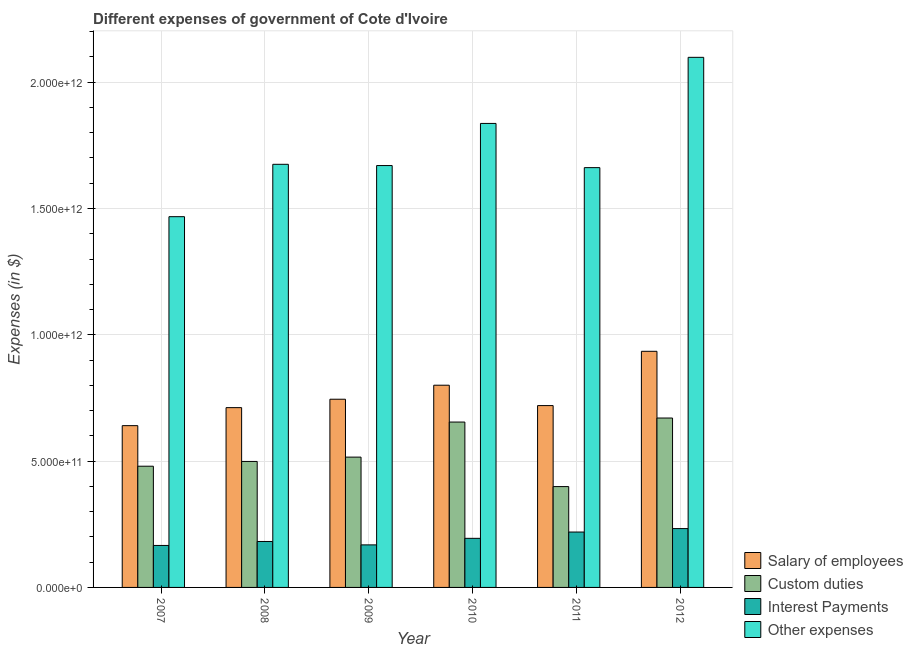How many different coloured bars are there?
Keep it short and to the point. 4. How many bars are there on the 3rd tick from the left?
Offer a terse response. 4. How many bars are there on the 5th tick from the right?
Give a very brief answer. 4. What is the label of the 3rd group of bars from the left?
Provide a succinct answer. 2009. What is the amount spent on other expenses in 2007?
Provide a short and direct response. 1.47e+12. Across all years, what is the maximum amount spent on interest payments?
Offer a very short reply. 2.33e+11. Across all years, what is the minimum amount spent on other expenses?
Provide a succinct answer. 1.47e+12. In which year was the amount spent on salary of employees maximum?
Give a very brief answer. 2012. What is the total amount spent on interest payments in the graph?
Give a very brief answer. 1.16e+12. What is the difference between the amount spent on interest payments in 2008 and that in 2009?
Provide a short and direct response. 1.35e+1. What is the difference between the amount spent on custom duties in 2009 and the amount spent on other expenses in 2011?
Ensure brevity in your answer.  1.17e+11. What is the average amount spent on salary of employees per year?
Your answer should be very brief. 7.59e+11. In the year 2010, what is the difference between the amount spent on custom duties and amount spent on salary of employees?
Offer a very short reply. 0. What is the ratio of the amount spent on salary of employees in 2009 to that in 2010?
Offer a terse response. 0.93. Is the amount spent on salary of employees in 2007 less than that in 2009?
Keep it short and to the point. Yes. Is the difference between the amount spent on custom duties in 2008 and 2011 greater than the difference between the amount spent on salary of employees in 2008 and 2011?
Provide a short and direct response. No. What is the difference between the highest and the second highest amount spent on interest payments?
Provide a short and direct response. 1.37e+1. What is the difference between the highest and the lowest amount spent on salary of employees?
Provide a succinct answer. 2.94e+11. In how many years, is the amount spent on other expenses greater than the average amount spent on other expenses taken over all years?
Provide a short and direct response. 2. What does the 1st bar from the left in 2012 represents?
Provide a succinct answer. Salary of employees. What does the 2nd bar from the right in 2011 represents?
Offer a very short reply. Interest Payments. How many years are there in the graph?
Keep it short and to the point. 6. What is the difference between two consecutive major ticks on the Y-axis?
Provide a succinct answer. 5.00e+11. Are the values on the major ticks of Y-axis written in scientific E-notation?
Give a very brief answer. Yes. Does the graph contain any zero values?
Provide a short and direct response. No. Does the graph contain grids?
Ensure brevity in your answer.  Yes. How are the legend labels stacked?
Your answer should be compact. Vertical. What is the title of the graph?
Keep it short and to the point. Different expenses of government of Cote d'Ivoire. What is the label or title of the X-axis?
Make the answer very short. Year. What is the label or title of the Y-axis?
Your response must be concise. Expenses (in $). What is the Expenses (in $) of Salary of employees in 2007?
Your response must be concise. 6.40e+11. What is the Expenses (in $) of Custom duties in 2007?
Provide a succinct answer. 4.80e+11. What is the Expenses (in $) in Interest Payments in 2007?
Provide a short and direct response. 1.66e+11. What is the Expenses (in $) of Other expenses in 2007?
Make the answer very short. 1.47e+12. What is the Expenses (in $) in Salary of employees in 2008?
Make the answer very short. 7.12e+11. What is the Expenses (in $) of Custom duties in 2008?
Provide a short and direct response. 4.99e+11. What is the Expenses (in $) in Interest Payments in 2008?
Provide a succinct answer. 1.82e+11. What is the Expenses (in $) in Other expenses in 2008?
Your answer should be compact. 1.67e+12. What is the Expenses (in $) of Salary of employees in 2009?
Give a very brief answer. 7.45e+11. What is the Expenses (in $) in Custom duties in 2009?
Provide a succinct answer. 5.16e+11. What is the Expenses (in $) of Interest Payments in 2009?
Provide a short and direct response. 1.68e+11. What is the Expenses (in $) in Other expenses in 2009?
Your answer should be compact. 1.67e+12. What is the Expenses (in $) of Salary of employees in 2010?
Provide a succinct answer. 8.00e+11. What is the Expenses (in $) in Custom duties in 2010?
Keep it short and to the point. 6.55e+11. What is the Expenses (in $) in Interest Payments in 2010?
Your response must be concise. 1.94e+11. What is the Expenses (in $) of Other expenses in 2010?
Provide a short and direct response. 1.84e+12. What is the Expenses (in $) of Salary of employees in 2011?
Your answer should be compact. 7.20e+11. What is the Expenses (in $) in Custom duties in 2011?
Make the answer very short. 3.99e+11. What is the Expenses (in $) of Interest Payments in 2011?
Your answer should be very brief. 2.19e+11. What is the Expenses (in $) in Other expenses in 2011?
Keep it short and to the point. 1.66e+12. What is the Expenses (in $) of Salary of employees in 2012?
Your answer should be compact. 9.35e+11. What is the Expenses (in $) in Custom duties in 2012?
Provide a succinct answer. 6.71e+11. What is the Expenses (in $) in Interest Payments in 2012?
Your answer should be compact. 2.33e+11. What is the Expenses (in $) in Other expenses in 2012?
Your answer should be very brief. 2.10e+12. Across all years, what is the maximum Expenses (in $) in Salary of employees?
Provide a succinct answer. 9.35e+11. Across all years, what is the maximum Expenses (in $) of Custom duties?
Your answer should be very brief. 6.71e+11. Across all years, what is the maximum Expenses (in $) of Interest Payments?
Your answer should be very brief. 2.33e+11. Across all years, what is the maximum Expenses (in $) of Other expenses?
Your response must be concise. 2.10e+12. Across all years, what is the minimum Expenses (in $) of Salary of employees?
Give a very brief answer. 6.40e+11. Across all years, what is the minimum Expenses (in $) in Custom duties?
Your answer should be very brief. 3.99e+11. Across all years, what is the minimum Expenses (in $) in Interest Payments?
Provide a short and direct response. 1.66e+11. Across all years, what is the minimum Expenses (in $) of Other expenses?
Make the answer very short. 1.47e+12. What is the total Expenses (in $) in Salary of employees in the graph?
Your response must be concise. 4.55e+12. What is the total Expenses (in $) of Custom duties in the graph?
Provide a succinct answer. 3.22e+12. What is the total Expenses (in $) in Interest Payments in the graph?
Provide a short and direct response. 1.16e+12. What is the total Expenses (in $) of Other expenses in the graph?
Ensure brevity in your answer.  1.04e+13. What is the difference between the Expenses (in $) of Salary of employees in 2007 and that in 2008?
Give a very brief answer. -7.13e+1. What is the difference between the Expenses (in $) in Custom duties in 2007 and that in 2008?
Offer a terse response. -1.89e+1. What is the difference between the Expenses (in $) of Interest Payments in 2007 and that in 2008?
Offer a very short reply. -1.57e+1. What is the difference between the Expenses (in $) in Other expenses in 2007 and that in 2008?
Offer a terse response. -2.07e+11. What is the difference between the Expenses (in $) in Salary of employees in 2007 and that in 2009?
Your response must be concise. -1.05e+11. What is the difference between the Expenses (in $) in Custom duties in 2007 and that in 2009?
Give a very brief answer. -3.60e+1. What is the difference between the Expenses (in $) in Interest Payments in 2007 and that in 2009?
Offer a terse response. -2.23e+09. What is the difference between the Expenses (in $) in Other expenses in 2007 and that in 2009?
Your answer should be compact. -2.02e+11. What is the difference between the Expenses (in $) in Salary of employees in 2007 and that in 2010?
Offer a very short reply. -1.60e+11. What is the difference between the Expenses (in $) in Custom duties in 2007 and that in 2010?
Ensure brevity in your answer.  -1.75e+11. What is the difference between the Expenses (in $) of Interest Payments in 2007 and that in 2010?
Keep it short and to the point. -2.81e+1. What is the difference between the Expenses (in $) of Other expenses in 2007 and that in 2010?
Your answer should be compact. -3.69e+11. What is the difference between the Expenses (in $) in Salary of employees in 2007 and that in 2011?
Your answer should be very brief. -7.94e+1. What is the difference between the Expenses (in $) in Custom duties in 2007 and that in 2011?
Your answer should be very brief. 8.06e+1. What is the difference between the Expenses (in $) of Interest Payments in 2007 and that in 2011?
Provide a succinct answer. -5.30e+1. What is the difference between the Expenses (in $) in Other expenses in 2007 and that in 2011?
Provide a short and direct response. -1.94e+11. What is the difference between the Expenses (in $) of Salary of employees in 2007 and that in 2012?
Your answer should be compact. -2.94e+11. What is the difference between the Expenses (in $) of Custom duties in 2007 and that in 2012?
Keep it short and to the point. -1.91e+11. What is the difference between the Expenses (in $) in Interest Payments in 2007 and that in 2012?
Offer a terse response. -6.67e+1. What is the difference between the Expenses (in $) of Other expenses in 2007 and that in 2012?
Your response must be concise. -6.31e+11. What is the difference between the Expenses (in $) of Salary of employees in 2008 and that in 2009?
Your answer should be very brief. -3.33e+1. What is the difference between the Expenses (in $) in Custom duties in 2008 and that in 2009?
Offer a very short reply. -1.71e+1. What is the difference between the Expenses (in $) of Interest Payments in 2008 and that in 2009?
Give a very brief answer. 1.35e+1. What is the difference between the Expenses (in $) in Other expenses in 2008 and that in 2009?
Keep it short and to the point. 4.94e+09. What is the difference between the Expenses (in $) of Salary of employees in 2008 and that in 2010?
Your response must be concise. -8.88e+1. What is the difference between the Expenses (in $) of Custom duties in 2008 and that in 2010?
Keep it short and to the point. -1.56e+11. What is the difference between the Expenses (in $) of Interest Payments in 2008 and that in 2010?
Offer a terse response. -1.24e+1. What is the difference between the Expenses (in $) in Other expenses in 2008 and that in 2010?
Offer a very short reply. -1.62e+11. What is the difference between the Expenses (in $) of Salary of employees in 2008 and that in 2011?
Offer a very short reply. -8.10e+09. What is the difference between the Expenses (in $) of Custom duties in 2008 and that in 2011?
Provide a succinct answer. 9.95e+1. What is the difference between the Expenses (in $) of Interest Payments in 2008 and that in 2011?
Your answer should be compact. -3.74e+1. What is the difference between the Expenses (in $) of Other expenses in 2008 and that in 2011?
Offer a terse response. 1.32e+1. What is the difference between the Expenses (in $) in Salary of employees in 2008 and that in 2012?
Your answer should be very brief. -2.23e+11. What is the difference between the Expenses (in $) in Custom duties in 2008 and that in 2012?
Offer a terse response. -1.72e+11. What is the difference between the Expenses (in $) of Interest Payments in 2008 and that in 2012?
Your answer should be compact. -5.10e+1. What is the difference between the Expenses (in $) of Other expenses in 2008 and that in 2012?
Give a very brief answer. -4.23e+11. What is the difference between the Expenses (in $) in Salary of employees in 2009 and that in 2010?
Keep it short and to the point. -5.55e+1. What is the difference between the Expenses (in $) of Custom duties in 2009 and that in 2010?
Provide a short and direct response. -1.39e+11. What is the difference between the Expenses (in $) of Interest Payments in 2009 and that in 2010?
Offer a very short reply. -2.59e+1. What is the difference between the Expenses (in $) of Other expenses in 2009 and that in 2010?
Your response must be concise. -1.67e+11. What is the difference between the Expenses (in $) in Salary of employees in 2009 and that in 2011?
Provide a succinct answer. 2.52e+1. What is the difference between the Expenses (in $) in Custom duties in 2009 and that in 2011?
Keep it short and to the point. 1.17e+11. What is the difference between the Expenses (in $) of Interest Payments in 2009 and that in 2011?
Provide a short and direct response. -5.08e+1. What is the difference between the Expenses (in $) of Other expenses in 2009 and that in 2011?
Offer a terse response. 8.24e+09. What is the difference between the Expenses (in $) of Salary of employees in 2009 and that in 2012?
Provide a short and direct response. -1.90e+11. What is the difference between the Expenses (in $) in Custom duties in 2009 and that in 2012?
Provide a short and direct response. -1.55e+11. What is the difference between the Expenses (in $) in Interest Payments in 2009 and that in 2012?
Keep it short and to the point. -6.45e+1. What is the difference between the Expenses (in $) in Other expenses in 2009 and that in 2012?
Give a very brief answer. -4.28e+11. What is the difference between the Expenses (in $) of Salary of employees in 2010 and that in 2011?
Your answer should be compact. 8.07e+1. What is the difference between the Expenses (in $) in Custom duties in 2010 and that in 2011?
Keep it short and to the point. 2.55e+11. What is the difference between the Expenses (in $) of Interest Payments in 2010 and that in 2011?
Give a very brief answer. -2.49e+1. What is the difference between the Expenses (in $) of Other expenses in 2010 and that in 2011?
Your answer should be compact. 1.75e+11. What is the difference between the Expenses (in $) in Salary of employees in 2010 and that in 2012?
Provide a short and direct response. -1.34e+11. What is the difference between the Expenses (in $) in Custom duties in 2010 and that in 2012?
Provide a succinct answer. -1.60e+1. What is the difference between the Expenses (in $) of Interest Payments in 2010 and that in 2012?
Your answer should be compact. -3.86e+1. What is the difference between the Expenses (in $) in Other expenses in 2010 and that in 2012?
Provide a succinct answer. -2.62e+11. What is the difference between the Expenses (in $) in Salary of employees in 2011 and that in 2012?
Ensure brevity in your answer.  -2.15e+11. What is the difference between the Expenses (in $) in Custom duties in 2011 and that in 2012?
Provide a succinct answer. -2.71e+11. What is the difference between the Expenses (in $) of Interest Payments in 2011 and that in 2012?
Keep it short and to the point. -1.37e+1. What is the difference between the Expenses (in $) in Other expenses in 2011 and that in 2012?
Offer a very short reply. -4.37e+11. What is the difference between the Expenses (in $) in Salary of employees in 2007 and the Expenses (in $) in Custom duties in 2008?
Provide a short and direct response. 1.42e+11. What is the difference between the Expenses (in $) of Salary of employees in 2007 and the Expenses (in $) of Interest Payments in 2008?
Your answer should be compact. 4.58e+11. What is the difference between the Expenses (in $) in Salary of employees in 2007 and the Expenses (in $) in Other expenses in 2008?
Your answer should be very brief. -1.03e+12. What is the difference between the Expenses (in $) of Custom duties in 2007 and the Expenses (in $) of Interest Payments in 2008?
Provide a short and direct response. 2.98e+11. What is the difference between the Expenses (in $) in Custom duties in 2007 and the Expenses (in $) in Other expenses in 2008?
Your response must be concise. -1.20e+12. What is the difference between the Expenses (in $) of Interest Payments in 2007 and the Expenses (in $) of Other expenses in 2008?
Your answer should be compact. -1.51e+12. What is the difference between the Expenses (in $) in Salary of employees in 2007 and the Expenses (in $) in Custom duties in 2009?
Provide a short and direct response. 1.25e+11. What is the difference between the Expenses (in $) in Salary of employees in 2007 and the Expenses (in $) in Interest Payments in 2009?
Provide a short and direct response. 4.72e+11. What is the difference between the Expenses (in $) of Salary of employees in 2007 and the Expenses (in $) of Other expenses in 2009?
Offer a terse response. -1.03e+12. What is the difference between the Expenses (in $) in Custom duties in 2007 and the Expenses (in $) in Interest Payments in 2009?
Keep it short and to the point. 3.11e+11. What is the difference between the Expenses (in $) in Custom duties in 2007 and the Expenses (in $) in Other expenses in 2009?
Ensure brevity in your answer.  -1.19e+12. What is the difference between the Expenses (in $) of Interest Payments in 2007 and the Expenses (in $) of Other expenses in 2009?
Give a very brief answer. -1.50e+12. What is the difference between the Expenses (in $) in Salary of employees in 2007 and the Expenses (in $) in Custom duties in 2010?
Make the answer very short. -1.42e+1. What is the difference between the Expenses (in $) of Salary of employees in 2007 and the Expenses (in $) of Interest Payments in 2010?
Keep it short and to the point. 4.46e+11. What is the difference between the Expenses (in $) of Salary of employees in 2007 and the Expenses (in $) of Other expenses in 2010?
Make the answer very short. -1.20e+12. What is the difference between the Expenses (in $) in Custom duties in 2007 and the Expenses (in $) in Interest Payments in 2010?
Offer a terse response. 2.85e+11. What is the difference between the Expenses (in $) in Custom duties in 2007 and the Expenses (in $) in Other expenses in 2010?
Your response must be concise. -1.36e+12. What is the difference between the Expenses (in $) of Interest Payments in 2007 and the Expenses (in $) of Other expenses in 2010?
Make the answer very short. -1.67e+12. What is the difference between the Expenses (in $) in Salary of employees in 2007 and the Expenses (in $) in Custom duties in 2011?
Offer a very short reply. 2.41e+11. What is the difference between the Expenses (in $) in Salary of employees in 2007 and the Expenses (in $) in Interest Payments in 2011?
Offer a terse response. 4.21e+11. What is the difference between the Expenses (in $) in Salary of employees in 2007 and the Expenses (in $) in Other expenses in 2011?
Offer a terse response. -1.02e+12. What is the difference between the Expenses (in $) in Custom duties in 2007 and the Expenses (in $) in Interest Payments in 2011?
Your answer should be very brief. 2.61e+11. What is the difference between the Expenses (in $) of Custom duties in 2007 and the Expenses (in $) of Other expenses in 2011?
Your answer should be compact. -1.18e+12. What is the difference between the Expenses (in $) in Interest Payments in 2007 and the Expenses (in $) in Other expenses in 2011?
Keep it short and to the point. -1.50e+12. What is the difference between the Expenses (in $) of Salary of employees in 2007 and the Expenses (in $) of Custom duties in 2012?
Provide a short and direct response. -3.02e+1. What is the difference between the Expenses (in $) in Salary of employees in 2007 and the Expenses (in $) in Interest Payments in 2012?
Your response must be concise. 4.07e+11. What is the difference between the Expenses (in $) of Salary of employees in 2007 and the Expenses (in $) of Other expenses in 2012?
Your answer should be very brief. -1.46e+12. What is the difference between the Expenses (in $) in Custom duties in 2007 and the Expenses (in $) in Interest Payments in 2012?
Make the answer very short. 2.47e+11. What is the difference between the Expenses (in $) of Custom duties in 2007 and the Expenses (in $) of Other expenses in 2012?
Keep it short and to the point. -1.62e+12. What is the difference between the Expenses (in $) in Interest Payments in 2007 and the Expenses (in $) in Other expenses in 2012?
Ensure brevity in your answer.  -1.93e+12. What is the difference between the Expenses (in $) in Salary of employees in 2008 and the Expenses (in $) in Custom duties in 2009?
Offer a very short reply. 1.96e+11. What is the difference between the Expenses (in $) in Salary of employees in 2008 and the Expenses (in $) in Interest Payments in 2009?
Your response must be concise. 5.43e+11. What is the difference between the Expenses (in $) of Salary of employees in 2008 and the Expenses (in $) of Other expenses in 2009?
Give a very brief answer. -9.58e+11. What is the difference between the Expenses (in $) in Custom duties in 2008 and the Expenses (in $) in Interest Payments in 2009?
Offer a very short reply. 3.30e+11. What is the difference between the Expenses (in $) in Custom duties in 2008 and the Expenses (in $) in Other expenses in 2009?
Ensure brevity in your answer.  -1.17e+12. What is the difference between the Expenses (in $) of Interest Payments in 2008 and the Expenses (in $) of Other expenses in 2009?
Your answer should be very brief. -1.49e+12. What is the difference between the Expenses (in $) in Salary of employees in 2008 and the Expenses (in $) in Custom duties in 2010?
Provide a short and direct response. 5.71e+1. What is the difference between the Expenses (in $) of Salary of employees in 2008 and the Expenses (in $) of Interest Payments in 2010?
Give a very brief answer. 5.17e+11. What is the difference between the Expenses (in $) of Salary of employees in 2008 and the Expenses (in $) of Other expenses in 2010?
Keep it short and to the point. -1.13e+12. What is the difference between the Expenses (in $) in Custom duties in 2008 and the Expenses (in $) in Interest Payments in 2010?
Offer a terse response. 3.04e+11. What is the difference between the Expenses (in $) in Custom duties in 2008 and the Expenses (in $) in Other expenses in 2010?
Offer a terse response. -1.34e+12. What is the difference between the Expenses (in $) of Interest Payments in 2008 and the Expenses (in $) of Other expenses in 2010?
Provide a short and direct response. -1.65e+12. What is the difference between the Expenses (in $) of Salary of employees in 2008 and the Expenses (in $) of Custom duties in 2011?
Offer a terse response. 3.12e+11. What is the difference between the Expenses (in $) in Salary of employees in 2008 and the Expenses (in $) in Interest Payments in 2011?
Give a very brief answer. 4.92e+11. What is the difference between the Expenses (in $) in Salary of employees in 2008 and the Expenses (in $) in Other expenses in 2011?
Offer a very short reply. -9.50e+11. What is the difference between the Expenses (in $) of Custom duties in 2008 and the Expenses (in $) of Interest Payments in 2011?
Provide a succinct answer. 2.79e+11. What is the difference between the Expenses (in $) in Custom duties in 2008 and the Expenses (in $) in Other expenses in 2011?
Offer a terse response. -1.16e+12. What is the difference between the Expenses (in $) of Interest Payments in 2008 and the Expenses (in $) of Other expenses in 2011?
Offer a terse response. -1.48e+12. What is the difference between the Expenses (in $) of Salary of employees in 2008 and the Expenses (in $) of Custom duties in 2012?
Keep it short and to the point. 4.11e+1. What is the difference between the Expenses (in $) in Salary of employees in 2008 and the Expenses (in $) in Interest Payments in 2012?
Your response must be concise. 4.79e+11. What is the difference between the Expenses (in $) in Salary of employees in 2008 and the Expenses (in $) in Other expenses in 2012?
Your response must be concise. -1.39e+12. What is the difference between the Expenses (in $) of Custom duties in 2008 and the Expenses (in $) of Interest Payments in 2012?
Give a very brief answer. 2.66e+11. What is the difference between the Expenses (in $) in Custom duties in 2008 and the Expenses (in $) in Other expenses in 2012?
Your response must be concise. -1.60e+12. What is the difference between the Expenses (in $) in Interest Payments in 2008 and the Expenses (in $) in Other expenses in 2012?
Your answer should be compact. -1.92e+12. What is the difference between the Expenses (in $) in Salary of employees in 2009 and the Expenses (in $) in Custom duties in 2010?
Offer a very short reply. 9.04e+1. What is the difference between the Expenses (in $) of Salary of employees in 2009 and the Expenses (in $) of Interest Payments in 2010?
Give a very brief answer. 5.51e+11. What is the difference between the Expenses (in $) of Salary of employees in 2009 and the Expenses (in $) of Other expenses in 2010?
Your response must be concise. -1.09e+12. What is the difference between the Expenses (in $) in Custom duties in 2009 and the Expenses (in $) in Interest Payments in 2010?
Your response must be concise. 3.21e+11. What is the difference between the Expenses (in $) of Custom duties in 2009 and the Expenses (in $) of Other expenses in 2010?
Ensure brevity in your answer.  -1.32e+12. What is the difference between the Expenses (in $) of Interest Payments in 2009 and the Expenses (in $) of Other expenses in 2010?
Provide a short and direct response. -1.67e+12. What is the difference between the Expenses (in $) of Salary of employees in 2009 and the Expenses (in $) of Custom duties in 2011?
Give a very brief answer. 3.46e+11. What is the difference between the Expenses (in $) in Salary of employees in 2009 and the Expenses (in $) in Interest Payments in 2011?
Your answer should be very brief. 5.26e+11. What is the difference between the Expenses (in $) in Salary of employees in 2009 and the Expenses (in $) in Other expenses in 2011?
Your answer should be compact. -9.17e+11. What is the difference between the Expenses (in $) in Custom duties in 2009 and the Expenses (in $) in Interest Payments in 2011?
Give a very brief answer. 2.97e+11. What is the difference between the Expenses (in $) in Custom duties in 2009 and the Expenses (in $) in Other expenses in 2011?
Offer a terse response. -1.15e+12. What is the difference between the Expenses (in $) in Interest Payments in 2009 and the Expenses (in $) in Other expenses in 2011?
Ensure brevity in your answer.  -1.49e+12. What is the difference between the Expenses (in $) in Salary of employees in 2009 and the Expenses (in $) in Custom duties in 2012?
Offer a very short reply. 7.44e+1. What is the difference between the Expenses (in $) of Salary of employees in 2009 and the Expenses (in $) of Interest Payments in 2012?
Keep it short and to the point. 5.12e+11. What is the difference between the Expenses (in $) in Salary of employees in 2009 and the Expenses (in $) in Other expenses in 2012?
Provide a short and direct response. -1.35e+12. What is the difference between the Expenses (in $) of Custom duties in 2009 and the Expenses (in $) of Interest Payments in 2012?
Provide a short and direct response. 2.83e+11. What is the difference between the Expenses (in $) of Custom duties in 2009 and the Expenses (in $) of Other expenses in 2012?
Provide a short and direct response. -1.58e+12. What is the difference between the Expenses (in $) in Interest Payments in 2009 and the Expenses (in $) in Other expenses in 2012?
Your answer should be very brief. -1.93e+12. What is the difference between the Expenses (in $) in Salary of employees in 2010 and the Expenses (in $) in Custom duties in 2011?
Keep it short and to the point. 4.01e+11. What is the difference between the Expenses (in $) of Salary of employees in 2010 and the Expenses (in $) of Interest Payments in 2011?
Provide a succinct answer. 5.81e+11. What is the difference between the Expenses (in $) of Salary of employees in 2010 and the Expenses (in $) of Other expenses in 2011?
Provide a succinct answer. -8.61e+11. What is the difference between the Expenses (in $) of Custom duties in 2010 and the Expenses (in $) of Interest Payments in 2011?
Your response must be concise. 4.35e+11. What is the difference between the Expenses (in $) in Custom duties in 2010 and the Expenses (in $) in Other expenses in 2011?
Provide a succinct answer. -1.01e+12. What is the difference between the Expenses (in $) in Interest Payments in 2010 and the Expenses (in $) in Other expenses in 2011?
Your answer should be very brief. -1.47e+12. What is the difference between the Expenses (in $) in Salary of employees in 2010 and the Expenses (in $) in Custom duties in 2012?
Give a very brief answer. 1.30e+11. What is the difference between the Expenses (in $) of Salary of employees in 2010 and the Expenses (in $) of Interest Payments in 2012?
Give a very brief answer. 5.68e+11. What is the difference between the Expenses (in $) in Salary of employees in 2010 and the Expenses (in $) in Other expenses in 2012?
Your response must be concise. -1.30e+12. What is the difference between the Expenses (in $) of Custom duties in 2010 and the Expenses (in $) of Interest Payments in 2012?
Your answer should be very brief. 4.22e+11. What is the difference between the Expenses (in $) of Custom duties in 2010 and the Expenses (in $) of Other expenses in 2012?
Make the answer very short. -1.44e+12. What is the difference between the Expenses (in $) of Interest Payments in 2010 and the Expenses (in $) of Other expenses in 2012?
Keep it short and to the point. -1.90e+12. What is the difference between the Expenses (in $) of Salary of employees in 2011 and the Expenses (in $) of Custom duties in 2012?
Keep it short and to the point. 4.92e+1. What is the difference between the Expenses (in $) in Salary of employees in 2011 and the Expenses (in $) in Interest Payments in 2012?
Keep it short and to the point. 4.87e+11. What is the difference between the Expenses (in $) in Salary of employees in 2011 and the Expenses (in $) in Other expenses in 2012?
Provide a succinct answer. -1.38e+12. What is the difference between the Expenses (in $) of Custom duties in 2011 and the Expenses (in $) of Interest Payments in 2012?
Give a very brief answer. 1.66e+11. What is the difference between the Expenses (in $) of Custom duties in 2011 and the Expenses (in $) of Other expenses in 2012?
Your response must be concise. -1.70e+12. What is the difference between the Expenses (in $) of Interest Payments in 2011 and the Expenses (in $) of Other expenses in 2012?
Keep it short and to the point. -1.88e+12. What is the average Expenses (in $) of Salary of employees per year?
Provide a succinct answer. 7.59e+11. What is the average Expenses (in $) of Custom duties per year?
Your answer should be compact. 5.36e+11. What is the average Expenses (in $) of Interest Payments per year?
Give a very brief answer. 1.94e+11. What is the average Expenses (in $) of Other expenses per year?
Your answer should be very brief. 1.73e+12. In the year 2007, what is the difference between the Expenses (in $) in Salary of employees and Expenses (in $) in Custom duties?
Ensure brevity in your answer.  1.61e+11. In the year 2007, what is the difference between the Expenses (in $) in Salary of employees and Expenses (in $) in Interest Payments?
Provide a succinct answer. 4.74e+11. In the year 2007, what is the difference between the Expenses (in $) in Salary of employees and Expenses (in $) in Other expenses?
Your answer should be compact. -8.27e+11. In the year 2007, what is the difference between the Expenses (in $) in Custom duties and Expenses (in $) in Interest Payments?
Provide a succinct answer. 3.14e+11. In the year 2007, what is the difference between the Expenses (in $) of Custom duties and Expenses (in $) of Other expenses?
Your answer should be very brief. -9.88e+11. In the year 2007, what is the difference between the Expenses (in $) in Interest Payments and Expenses (in $) in Other expenses?
Ensure brevity in your answer.  -1.30e+12. In the year 2008, what is the difference between the Expenses (in $) in Salary of employees and Expenses (in $) in Custom duties?
Offer a terse response. 2.13e+11. In the year 2008, what is the difference between the Expenses (in $) of Salary of employees and Expenses (in $) of Interest Payments?
Give a very brief answer. 5.30e+11. In the year 2008, what is the difference between the Expenses (in $) of Salary of employees and Expenses (in $) of Other expenses?
Provide a short and direct response. -9.63e+11. In the year 2008, what is the difference between the Expenses (in $) in Custom duties and Expenses (in $) in Interest Payments?
Make the answer very short. 3.17e+11. In the year 2008, what is the difference between the Expenses (in $) of Custom duties and Expenses (in $) of Other expenses?
Make the answer very short. -1.18e+12. In the year 2008, what is the difference between the Expenses (in $) of Interest Payments and Expenses (in $) of Other expenses?
Your answer should be compact. -1.49e+12. In the year 2009, what is the difference between the Expenses (in $) of Salary of employees and Expenses (in $) of Custom duties?
Offer a very short reply. 2.29e+11. In the year 2009, what is the difference between the Expenses (in $) of Salary of employees and Expenses (in $) of Interest Payments?
Your answer should be compact. 5.77e+11. In the year 2009, what is the difference between the Expenses (in $) in Salary of employees and Expenses (in $) in Other expenses?
Give a very brief answer. -9.25e+11. In the year 2009, what is the difference between the Expenses (in $) in Custom duties and Expenses (in $) in Interest Payments?
Offer a very short reply. 3.47e+11. In the year 2009, what is the difference between the Expenses (in $) of Custom duties and Expenses (in $) of Other expenses?
Keep it short and to the point. -1.15e+12. In the year 2009, what is the difference between the Expenses (in $) of Interest Payments and Expenses (in $) of Other expenses?
Your answer should be very brief. -1.50e+12. In the year 2010, what is the difference between the Expenses (in $) in Salary of employees and Expenses (in $) in Custom duties?
Offer a very short reply. 1.46e+11. In the year 2010, what is the difference between the Expenses (in $) of Salary of employees and Expenses (in $) of Interest Payments?
Give a very brief answer. 6.06e+11. In the year 2010, what is the difference between the Expenses (in $) of Salary of employees and Expenses (in $) of Other expenses?
Provide a short and direct response. -1.04e+12. In the year 2010, what is the difference between the Expenses (in $) in Custom duties and Expenses (in $) in Interest Payments?
Your answer should be very brief. 4.60e+11. In the year 2010, what is the difference between the Expenses (in $) in Custom duties and Expenses (in $) in Other expenses?
Offer a very short reply. -1.18e+12. In the year 2010, what is the difference between the Expenses (in $) in Interest Payments and Expenses (in $) in Other expenses?
Give a very brief answer. -1.64e+12. In the year 2011, what is the difference between the Expenses (in $) in Salary of employees and Expenses (in $) in Custom duties?
Your response must be concise. 3.21e+11. In the year 2011, what is the difference between the Expenses (in $) of Salary of employees and Expenses (in $) of Interest Payments?
Your answer should be very brief. 5.01e+11. In the year 2011, what is the difference between the Expenses (in $) in Salary of employees and Expenses (in $) in Other expenses?
Make the answer very short. -9.42e+11. In the year 2011, what is the difference between the Expenses (in $) in Custom duties and Expenses (in $) in Interest Payments?
Your response must be concise. 1.80e+11. In the year 2011, what is the difference between the Expenses (in $) of Custom duties and Expenses (in $) of Other expenses?
Give a very brief answer. -1.26e+12. In the year 2011, what is the difference between the Expenses (in $) in Interest Payments and Expenses (in $) in Other expenses?
Provide a succinct answer. -1.44e+12. In the year 2012, what is the difference between the Expenses (in $) in Salary of employees and Expenses (in $) in Custom duties?
Provide a short and direct response. 2.64e+11. In the year 2012, what is the difference between the Expenses (in $) in Salary of employees and Expenses (in $) in Interest Payments?
Give a very brief answer. 7.02e+11. In the year 2012, what is the difference between the Expenses (in $) of Salary of employees and Expenses (in $) of Other expenses?
Ensure brevity in your answer.  -1.16e+12. In the year 2012, what is the difference between the Expenses (in $) in Custom duties and Expenses (in $) in Interest Payments?
Provide a succinct answer. 4.38e+11. In the year 2012, what is the difference between the Expenses (in $) in Custom duties and Expenses (in $) in Other expenses?
Give a very brief answer. -1.43e+12. In the year 2012, what is the difference between the Expenses (in $) in Interest Payments and Expenses (in $) in Other expenses?
Make the answer very short. -1.87e+12. What is the ratio of the Expenses (in $) in Salary of employees in 2007 to that in 2008?
Offer a terse response. 0.9. What is the ratio of the Expenses (in $) in Custom duties in 2007 to that in 2008?
Offer a terse response. 0.96. What is the ratio of the Expenses (in $) in Interest Payments in 2007 to that in 2008?
Ensure brevity in your answer.  0.91. What is the ratio of the Expenses (in $) of Other expenses in 2007 to that in 2008?
Provide a short and direct response. 0.88. What is the ratio of the Expenses (in $) in Salary of employees in 2007 to that in 2009?
Offer a very short reply. 0.86. What is the ratio of the Expenses (in $) in Custom duties in 2007 to that in 2009?
Your response must be concise. 0.93. What is the ratio of the Expenses (in $) in Interest Payments in 2007 to that in 2009?
Your response must be concise. 0.99. What is the ratio of the Expenses (in $) in Other expenses in 2007 to that in 2009?
Offer a terse response. 0.88. What is the ratio of the Expenses (in $) of Custom duties in 2007 to that in 2010?
Keep it short and to the point. 0.73. What is the ratio of the Expenses (in $) of Interest Payments in 2007 to that in 2010?
Your response must be concise. 0.86. What is the ratio of the Expenses (in $) in Other expenses in 2007 to that in 2010?
Make the answer very short. 0.8. What is the ratio of the Expenses (in $) of Salary of employees in 2007 to that in 2011?
Your response must be concise. 0.89. What is the ratio of the Expenses (in $) in Custom duties in 2007 to that in 2011?
Offer a very short reply. 1.2. What is the ratio of the Expenses (in $) of Interest Payments in 2007 to that in 2011?
Your answer should be compact. 0.76. What is the ratio of the Expenses (in $) of Other expenses in 2007 to that in 2011?
Your response must be concise. 0.88. What is the ratio of the Expenses (in $) in Salary of employees in 2007 to that in 2012?
Keep it short and to the point. 0.69. What is the ratio of the Expenses (in $) in Custom duties in 2007 to that in 2012?
Ensure brevity in your answer.  0.72. What is the ratio of the Expenses (in $) in Interest Payments in 2007 to that in 2012?
Offer a very short reply. 0.71. What is the ratio of the Expenses (in $) of Other expenses in 2007 to that in 2012?
Ensure brevity in your answer.  0.7. What is the ratio of the Expenses (in $) in Salary of employees in 2008 to that in 2009?
Provide a short and direct response. 0.96. What is the ratio of the Expenses (in $) in Custom duties in 2008 to that in 2009?
Provide a succinct answer. 0.97. What is the ratio of the Expenses (in $) in Salary of employees in 2008 to that in 2010?
Give a very brief answer. 0.89. What is the ratio of the Expenses (in $) of Custom duties in 2008 to that in 2010?
Ensure brevity in your answer.  0.76. What is the ratio of the Expenses (in $) in Interest Payments in 2008 to that in 2010?
Provide a short and direct response. 0.94. What is the ratio of the Expenses (in $) of Other expenses in 2008 to that in 2010?
Make the answer very short. 0.91. What is the ratio of the Expenses (in $) in Salary of employees in 2008 to that in 2011?
Your response must be concise. 0.99. What is the ratio of the Expenses (in $) of Custom duties in 2008 to that in 2011?
Offer a terse response. 1.25. What is the ratio of the Expenses (in $) of Interest Payments in 2008 to that in 2011?
Provide a succinct answer. 0.83. What is the ratio of the Expenses (in $) in Other expenses in 2008 to that in 2011?
Provide a short and direct response. 1.01. What is the ratio of the Expenses (in $) in Salary of employees in 2008 to that in 2012?
Offer a terse response. 0.76. What is the ratio of the Expenses (in $) in Custom duties in 2008 to that in 2012?
Keep it short and to the point. 0.74. What is the ratio of the Expenses (in $) of Interest Payments in 2008 to that in 2012?
Provide a short and direct response. 0.78. What is the ratio of the Expenses (in $) in Other expenses in 2008 to that in 2012?
Provide a succinct answer. 0.8. What is the ratio of the Expenses (in $) of Salary of employees in 2009 to that in 2010?
Ensure brevity in your answer.  0.93. What is the ratio of the Expenses (in $) in Custom duties in 2009 to that in 2010?
Provide a short and direct response. 0.79. What is the ratio of the Expenses (in $) in Interest Payments in 2009 to that in 2010?
Offer a very short reply. 0.87. What is the ratio of the Expenses (in $) of Other expenses in 2009 to that in 2010?
Your answer should be compact. 0.91. What is the ratio of the Expenses (in $) in Salary of employees in 2009 to that in 2011?
Your answer should be very brief. 1.03. What is the ratio of the Expenses (in $) of Custom duties in 2009 to that in 2011?
Your answer should be compact. 1.29. What is the ratio of the Expenses (in $) in Interest Payments in 2009 to that in 2011?
Provide a succinct answer. 0.77. What is the ratio of the Expenses (in $) in Salary of employees in 2009 to that in 2012?
Give a very brief answer. 0.8. What is the ratio of the Expenses (in $) of Custom duties in 2009 to that in 2012?
Ensure brevity in your answer.  0.77. What is the ratio of the Expenses (in $) of Interest Payments in 2009 to that in 2012?
Offer a terse response. 0.72. What is the ratio of the Expenses (in $) in Other expenses in 2009 to that in 2012?
Keep it short and to the point. 0.8. What is the ratio of the Expenses (in $) in Salary of employees in 2010 to that in 2011?
Keep it short and to the point. 1.11. What is the ratio of the Expenses (in $) of Custom duties in 2010 to that in 2011?
Give a very brief answer. 1.64. What is the ratio of the Expenses (in $) of Interest Payments in 2010 to that in 2011?
Give a very brief answer. 0.89. What is the ratio of the Expenses (in $) in Other expenses in 2010 to that in 2011?
Make the answer very short. 1.11. What is the ratio of the Expenses (in $) of Salary of employees in 2010 to that in 2012?
Ensure brevity in your answer.  0.86. What is the ratio of the Expenses (in $) of Custom duties in 2010 to that in 2012?
Your answer should be compact. 0.98. What is the ratio of the Expenses (in $) of Interest Payments in 2010 to that in 2012?
Your answer should be compact. 0.83. What is the ratio of the Expenses (in $) of Other expenses in 2010 to that in 2012?
Give a very brief answer. 0.88. What is the ratio of the Expenses (in $) of Salary of employees in 2011 to that in 2012?
Give a very brief answer. 0.77. What is the ratio of the Expenses (in $) of Custom duties in 2011 to that in 2012?
Offer a very short reply. 0.6. What is the ratio of the Expenses (in $) in Interest Payments in 2011 to that in 2012?
Provide a short and direct response. 0.94. What is the ratio of the Expenses (in $) of Other expenses in 2011 to that in 2012?
Offer a terse response. 0.79. What is the difference between the highest and the second highest Expenses (in $) in Salary of employees?
Provide a short and direct response. 1.34e+11. What is the difference between the highest and the second highest Expenses (in $) of Custom duties?
Offer a very short reply. 1.60e+1. What is the difference between the highest and the second highest Expenses (in $) of Interest Payments?
Your response must be concise. 1.37e+1. What is the difference between the highest and the second highest Expenses (in $) of Other expenses?
Offer a terse response. 2.62e+11. What is the difference between the highest and the lowest Expenses (in $) of Salary of employees?
Ensure brevity in your answer.  2.94e+11. What is the difference between the highest and the lowest Expenses (in $) of Custom duties?
Your answer should be compact. 2.71e+11. What is the difference between the highest and the lowest Expenses (in $) in Interest Payments?
Offer a terse response. 6.67e+1. What is the difference between the highest and the lowest Expenses (in $) in Other expenses?
Ensure brevity in your answer.  6.31e+11. 